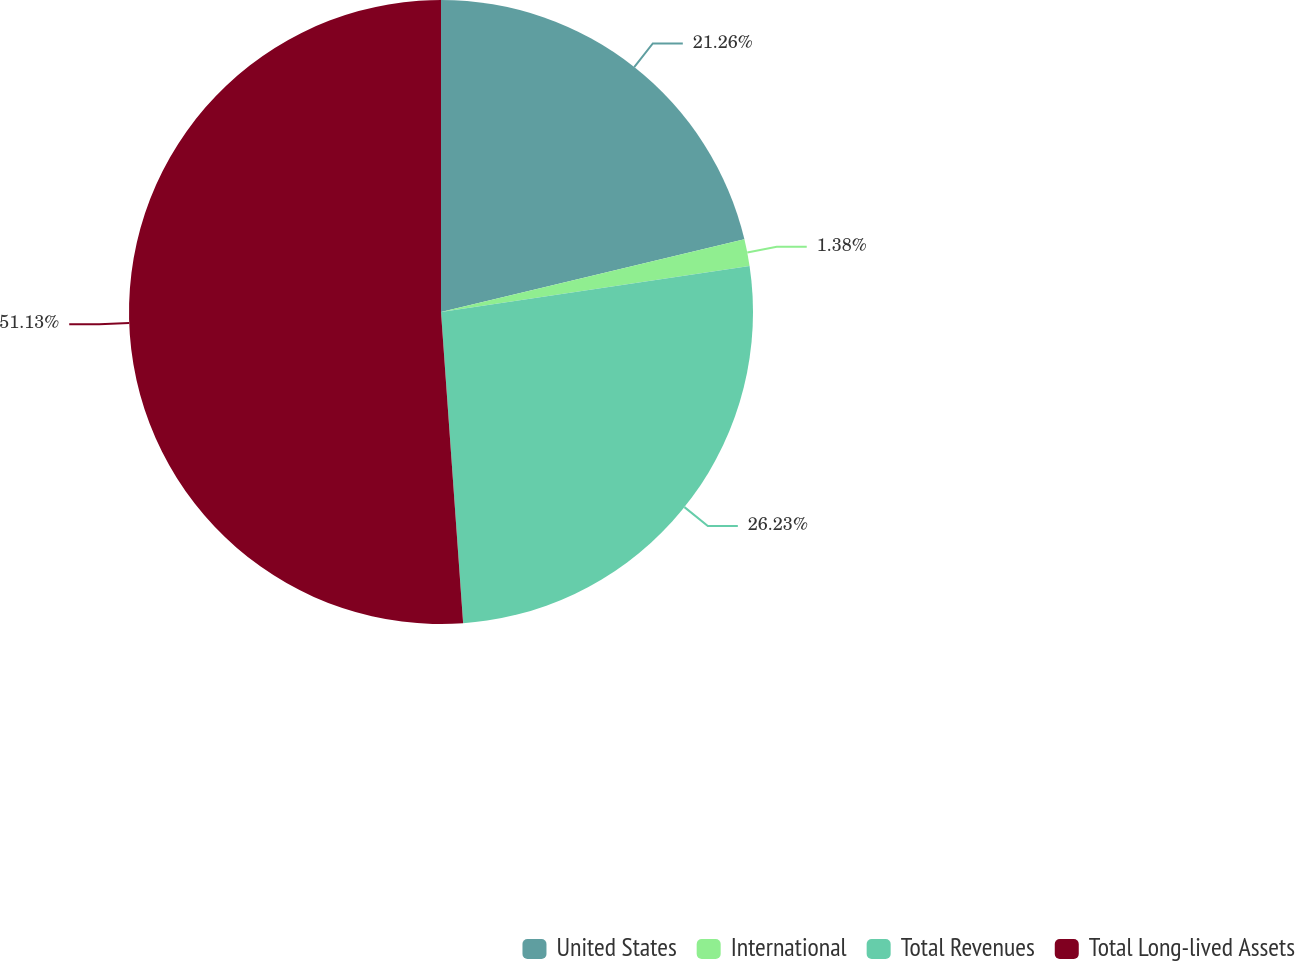<chart> <loc_0><loc_0><loc_500><loc_500><pie_chart><fcel>United States<fcel>International<fcel>Total Revenues<fcel>Total Long-lived Assets<nl><fcel>21.26%<fcel>1.38%<fcel>26.23%<fcel>51.13%<nl></chart> 